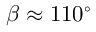Convert formula to latex. <formula><loc_0><loc_0><loc_500><loc_500>\beta \approx 1 1 0 ^ { \circ }</formula> 